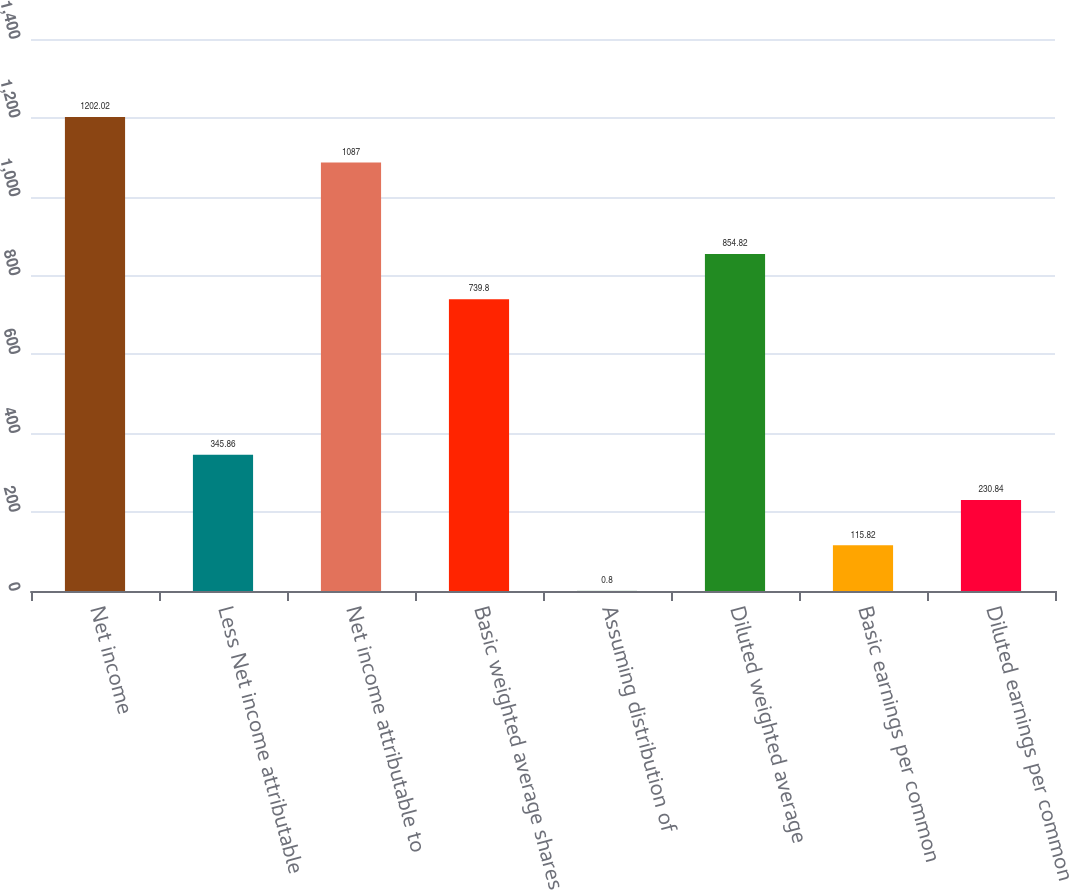Convert chart to OTSL. <chart><loc_0><loc_0><loc_500><loc_500><bar_chart><fcel>Net income<fcel>Less Net income attributable<fcel>Net income attributable to<fcel>Basic weighted average shares<fcel>Assuming distribution of<fcel>Diluted weighted average<fcel>Basic earnings per common<fcel>Diluted earnings per common<nl><fcel>1202.02<fcel>345.86<fcel>1087<fcel>739.8<fcel>0.8<fcel>854.82<fcel>115.82<fcel>230.84<nl></chart> 